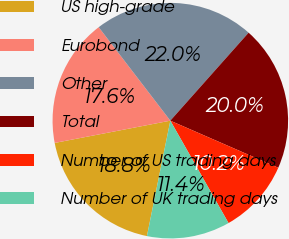<chart> <loc_0><loc_0><loc_500><loc_500><pie_chart><fcel>US high-grade<fcel>Eurobond<fcel>Other<fcel>Total<fcel>Number of US trading days<fcel>Number of UK trading days<nl><fcel>18.79%<fcel>17.62%<fcel>21.98%<fcel>19.97%<fcel>10.23%<fcel>11.41%<nl></chart> 